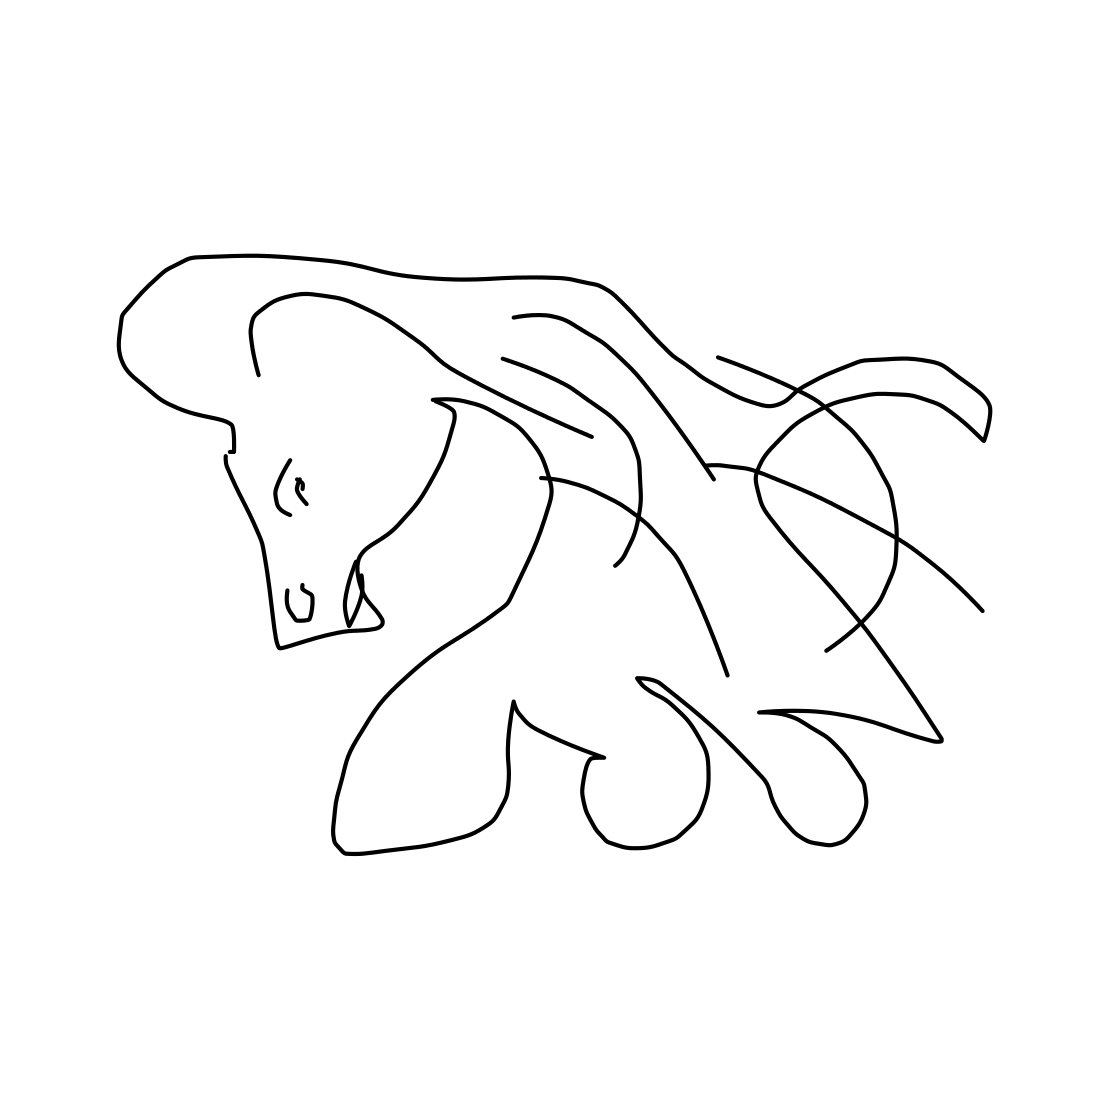In the scene, is a horse in it? Yes 